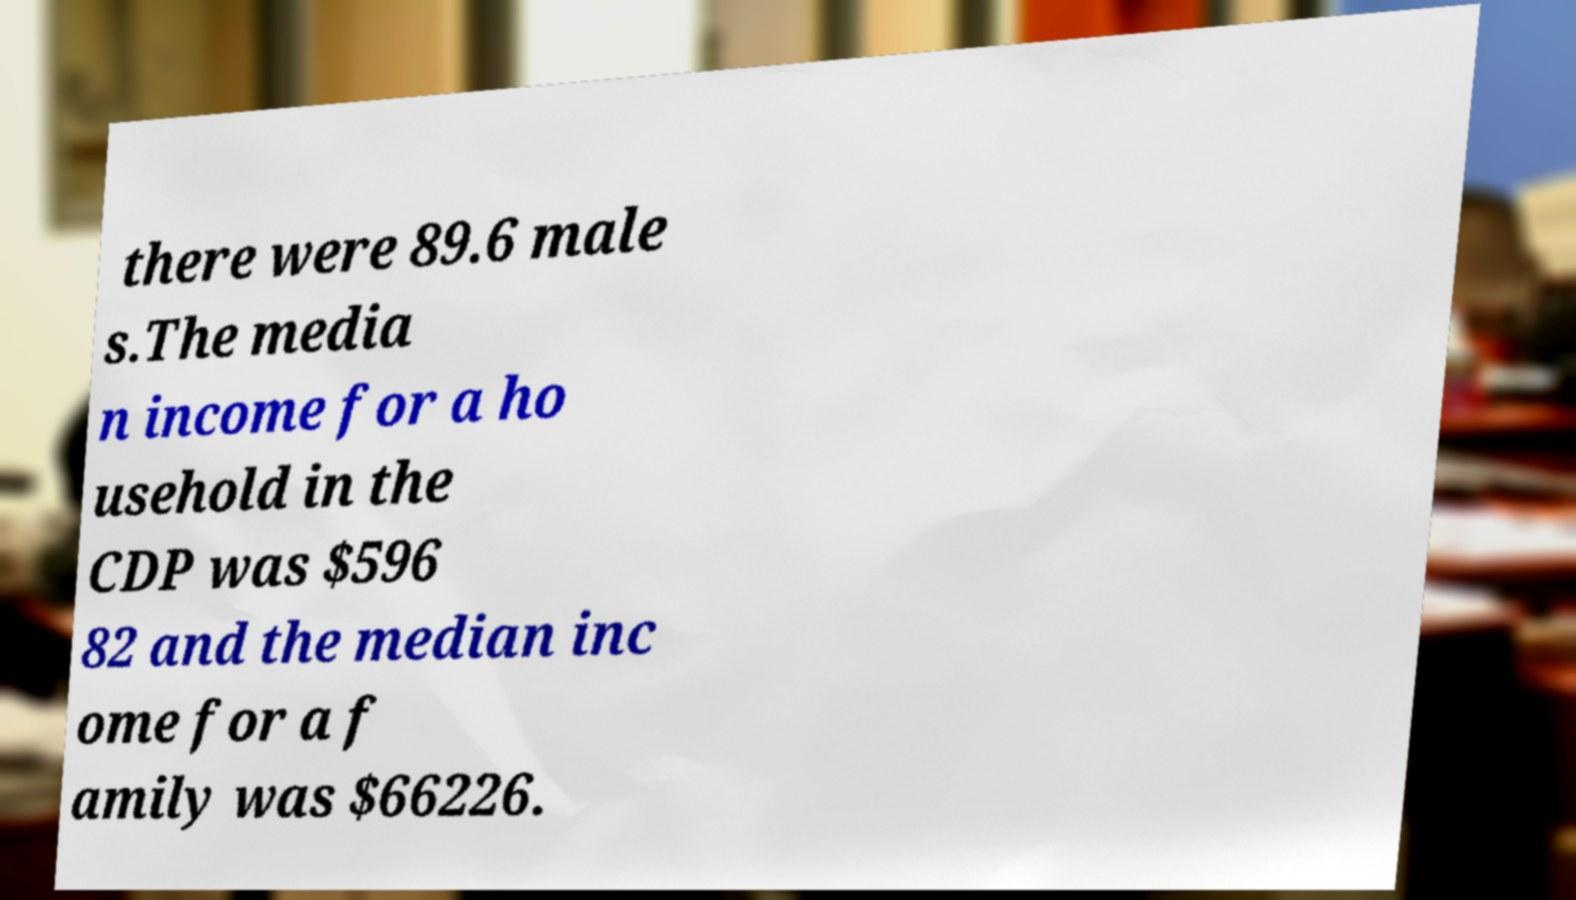Can you accurately transcribe the text from the provided image for me? there were 89.6 male s.The media n income for a ho usehold in the CDP was $596 82 and the median inc ome for a f amily was $66226. 